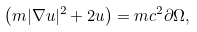<formula> <loc_0><loc_0><loc_500><loc_500>\left ( m | \nabla u | ^ { 2 } + 2 u \right ) = m c ^ { 2 } \partial \Omega ,</formula> 